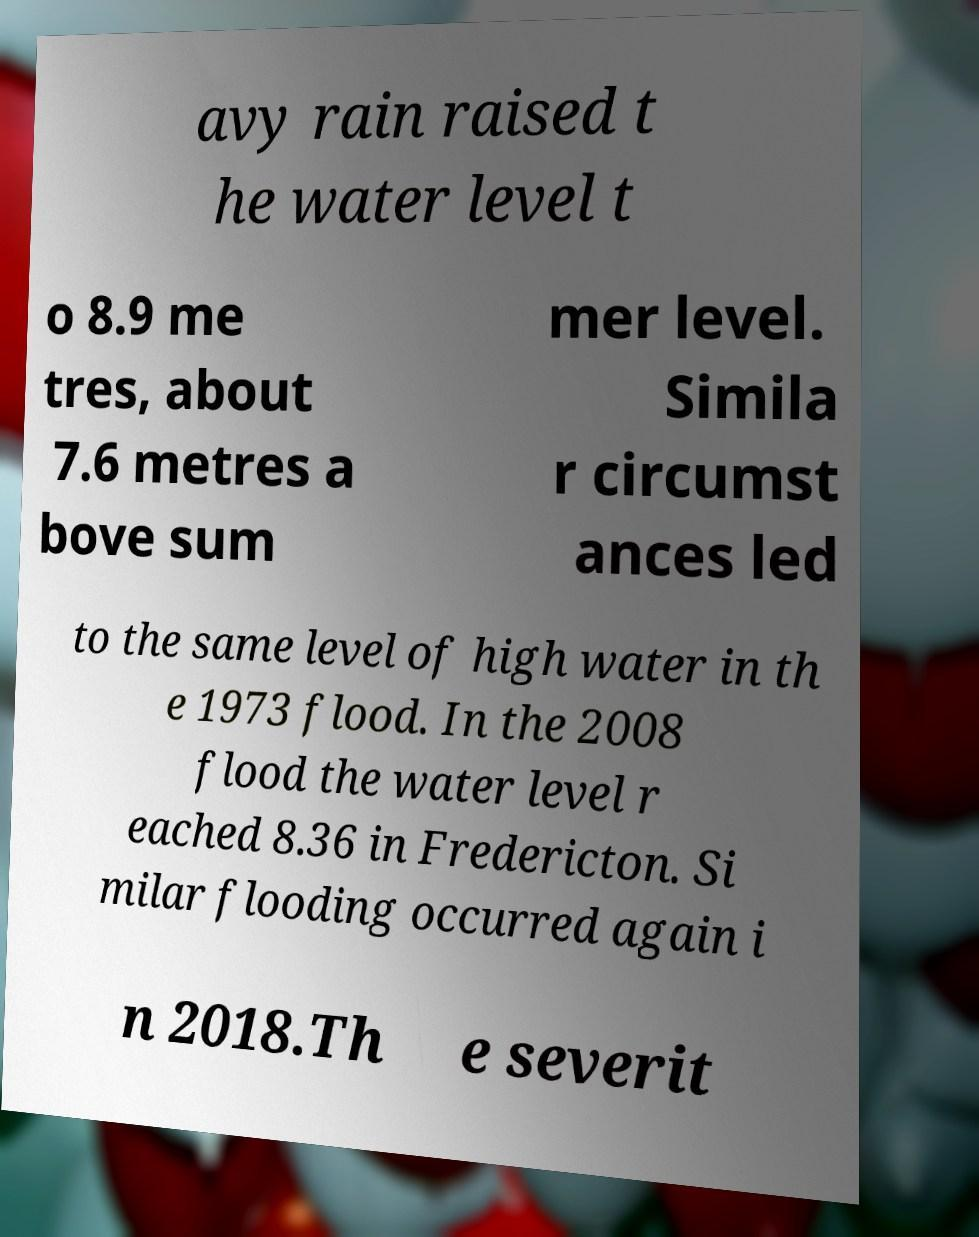Could you extract and type out the text from this image? avy rain raised t he water level t o 8.9 me tres, about 7.6 metres a bove sum mer level. Simila r circumst ances led to the same level of high water in th e 1973 flood. In the 2008 flood the water level r eached 8.36 in Fredericton. Si milar flooding occurred again i n 2018.Th e severit 